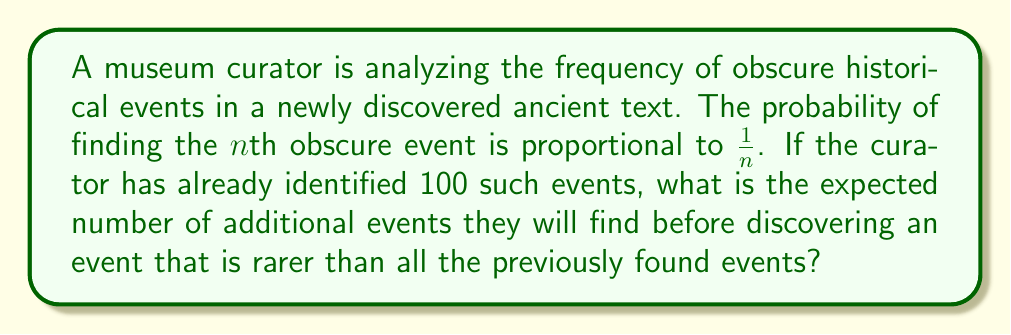Can you answer this question? Let's approach this step-by-step:

1) This problem is related to the harmonic series. The expected number of additional events is given by the sum of the reciprocals from 101 to infinity.

2) Mathematically, this can be expressed as:

   $$E = \sum_{n=101}^{\infty} \frac{1}{n}$$

3) This is a partial harmonic series. The full harmonic series diverges, but we can approximate this sum.

4) We can use the integral test to estimate this sum. The integral approximation is:

   $$\int_{101}^{\infty} \frac{1}{x} dx = \lim_{b \to \infty} [\ln(x)]_{101}^{b} = \lim_{b \to \infty} (\ln(b) - \ln(101))$$

5) As $b$ approaches infinity, $\ln(b)$ also approaches infinity. However, $\ln(101)$ is a constant.

6) Therefore, our approximation is:

   $$E \approx \infty - \ln(101) = \infty$$

7) While this approximation suggests the expected number is infinite, in reality, it's more accurate to say that the expected number is very large and doesn't converge to a finite value.
Answer: The expected number does not converge; it approaches infinity. 